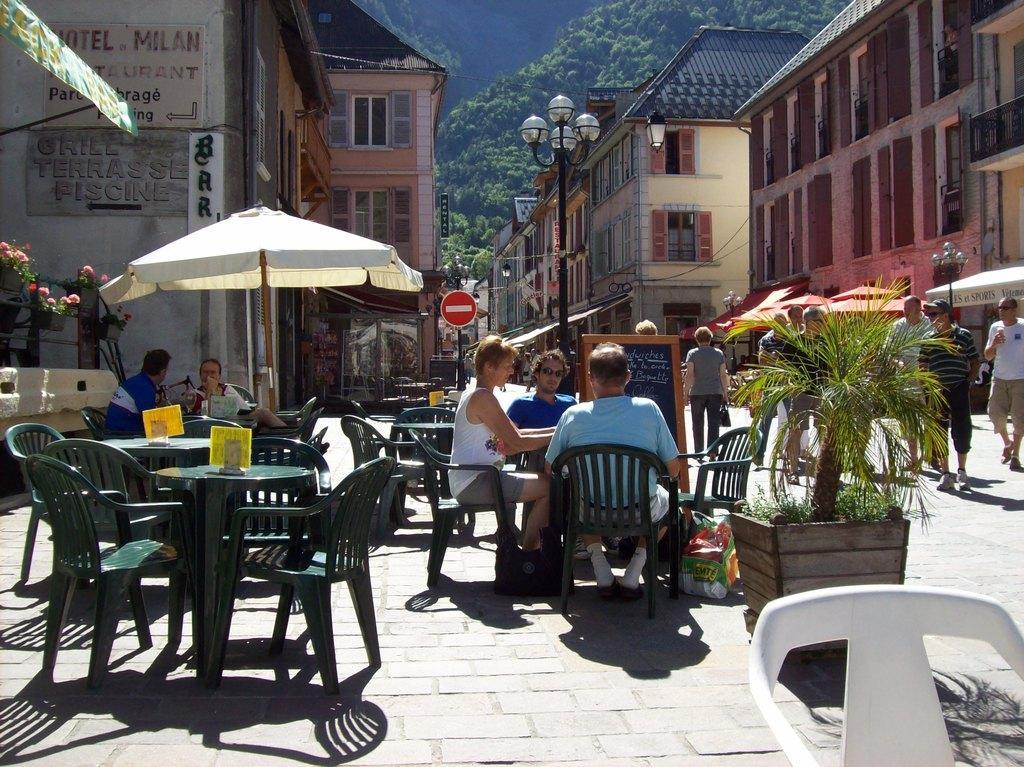Can you describe this image briefly? This is a picture of a street where we can see some buildings around and the pillar in between the street and to the left side we can see some chairs and tables on which the people are sitting and also some plants and people walking around them. 